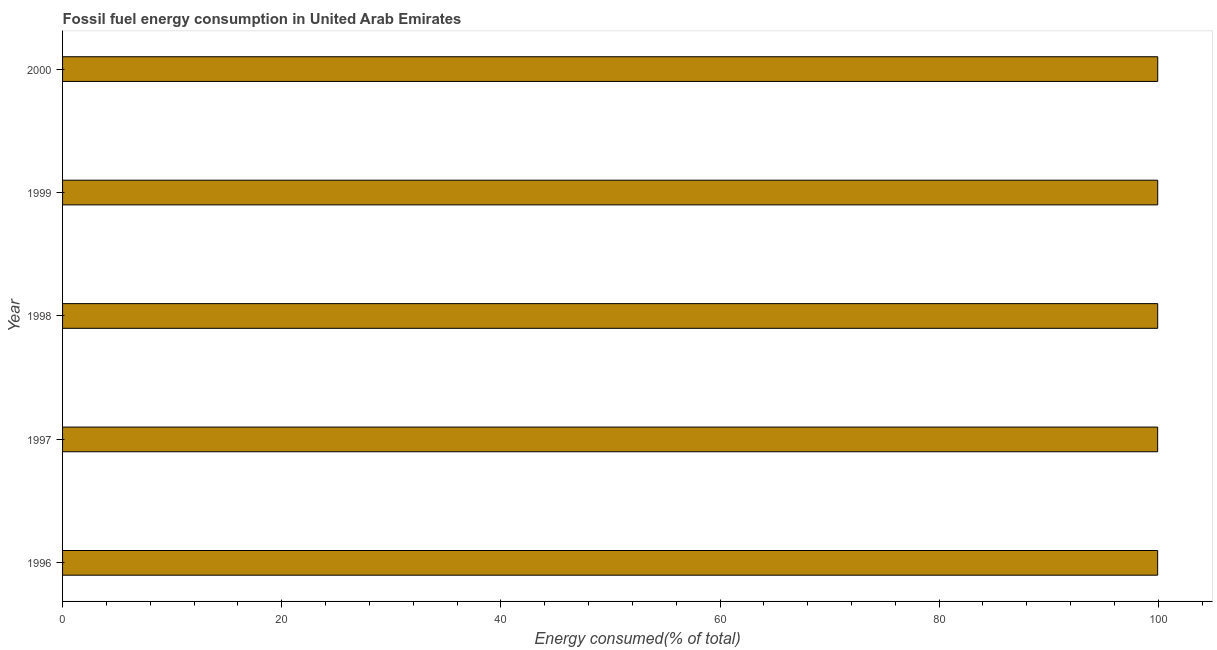Does the graph contain any zero values?
Your answer should be very brief. No. Does the graph contain grids?
Keep it short and to the point. No. What is the title of the graph?
Your response must be concise. Fossil fuel energy consumption in United Arab Emirates. What is the label or title of the X-axis?
Your response must be concise. Energy consumed(% of total). What is the label or title of the Y-axis?
Offer a very short reply. Year. What is the fossil fuel energy consumption in 1999?
Make the answer very short. 99.95. Across all years, what is the maximum fossil fuel energy consumption?
Your response must be concise. 99.95. Across all years, what is the minimum fossil fuel energy consumption?
Provide a succinct answer. 99.94. In which year was the fossil fuel energy consumption maximum?
Your response must be concise. 2000. In which year was the fossil fuel energy consumption minimum?
Your response must be concise. 1997. What is the sum of the fossil fuel energy consumption?
Your answer should be very brief. 499.73. What is the difference between the fossil fuel energy consumption in 1998 and 2000?
Your response must be concise. -0. What is the average fossil fuel energy consumption per year?
Ensure brevity in your answer.  99.95. What is the median fossil fuel energy consumption?
Provide a short and direct response. 99.95. In how many years, is the fossil fuel energy consumption greater than 8 %?
Your response must be concise. 5. Do a majority of the years between 2000 and 1997 (inclusive) have fossil fuel energy consumption greater than 28 %?
Offer a very short reply. Yes. What is the ratio of the fossil fuel energy consumption in 1997 to that in 1999?
Offer a terse response. 1. Is the fossil fuel energy consumption in 1996 less than that in 1999?
Your answer should be very brief. Yes. What is the difference between the highest and the second highest fossil fuel energy consumption?
Give a very brief answer. 0. What is the difference between the highest and the lowest fossil fuel energy consumption?
Keep it short and to the point. 0.01. How many bars are there?
Keep it short and to the point. 5. Are all the bars in the graph horizontal?
Give a very brief answer. Yes. What is the difference between two consecutive major ticks on the X-axis?
Provide a succinct answer. 20. Are the values on the major ticks of X-axis written in scientific E-notation?
Ensure brevity in your answer.  No. What is the Energy consumed(% of total) of 1996?
Provide a succinct answer. 99.94. What is the Energy consumed(% of total) in 1997?
Provide a succinct answer. 99.94. What is the Energy consumed(% of total) in 1998?
Your answer should be very brief. 99.95. What is the Energy consumed(% of total) of 1999?
Your answer should be compact. 99.95. What is the Energy consumed(% of total) of 2000?
Your answer should be compact. 99.95. What is the difference between the Energy consumed(% of total) in 1996 and 1997?
Provide a succinct answer. 0. What is the difference between the Energy consumed(% of total) in 1996 and 1998?
Ensure brevity in your answer.  -0. What is the difference between the Energy consumed(% of total) in 1996 and 1999?
Provide a short and direct response. -0. What is the difference between the Energy consumed(% of total) in 1996 and 2000?
Your answer should be compact. -0.01. What is the difference between the Energy consumed(% of total) in 1997 and 1998?
Offer a very short reply. -0. What is the difference between the Energy consumed(% of total) in 1997 and 1999?
Give a very brief answer. -0.01. What is the difference between the Energy consumed(% of total) in 1997 and 2000?
Give a very brief answer. -0.01. What is the difference between the Energy consumed(% of total) in 1998 and 1999?
Give a very brief answer. -0. What is the difference between the Energy consumed(% of total) in 1998 and 2000?
Your answer should be very brief. -0. What is the difference between the Energy consumed(% of total) in 1999 and 2000?
Keep it short and to the point. -0. What is the ratio of the Energy consumed(% of total) in 1996 to that in 1998?
Provide a short and direct response. 1. What is the ratio of the Energy consumed(% of total) in 1996 to that in 2000?
Give a very brief answer. 1. What is the ratio of the Energy consumed(% of total) in 1997 to that in 2000?
Offer a terse response. 1. What is the ratio of the Energy consumed(% of total) in 1998 to that in 1999?
Make the answer very short. 1. What is the ratio of the Energy consumed(% of total) in 1998 to that in 2000?
Your answer should be very brief. 1. What is the ratio of the Energy consumed(% of total) in 1999 to that in 2000?
Your answer should be compact. 1. 